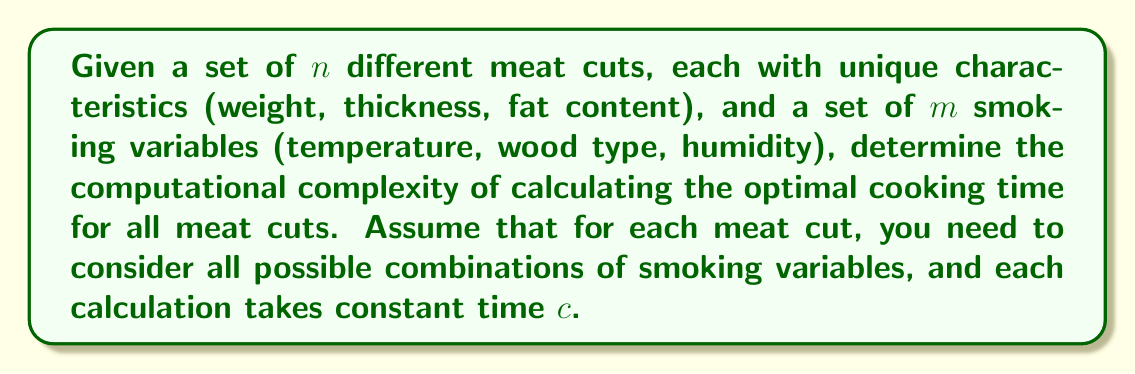Give your solution to this math problem. To solve this problem, let's break it down step-by-step:

1) For each meat cut, we need to consider all possible combinations of smoking variables. The number of combinations is $m$.

2) We have $n$ different meat cuts, and for each cut, we need to perform $m$ calculations.

3) Each calculation takes constant time $c$.

4) Therefore, the total number of operations is:

   $$n \times m \times c$$

5) In big O notation, we ignore constant factors. So, we can remove $c$ from our consideration:

   $$O(n \times m)$$

6) The computational complexity is thus $O(nm)$, which is polynomial time.

7) In the worst case, if $m$ is proportional to $n$ (i.e., $m = kn$ for some constant $k$), the complexity would be $O(n^2)$.

8) However, in most practical scenarios, the number of smoking variables ($m$) would be fixed and much smaller than the number of meat cuts ($n$). In this case, $m$ can be considered a constant, and the complexity simplifies to $O(n)$.

This analysis shows that the algorithm's efficiency is primarily dependent on the number of meat cuts, assuming a reasonable number of smoking variables.
Answer: The computational complexity is $O(nm)$, which simplifies to $O(n)$ if $m$ is considered constant. 